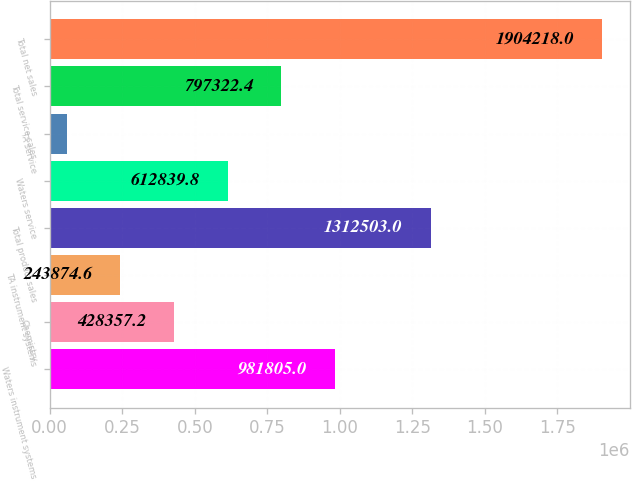Convert chart. <chart><loc_0><loc_0><loc_500><loc_500><bar_chart><fcel>Waters instrument systems<fcel>Chemistry<fcel>TA instrument systems<fcel>Total product sales<fcel>Waters service<fcel>TA service<fcel>Total service sales<fcel>Total net sales<nl><fcel>981805<fcel>428357<fcel>243875<fcel>1.3125e+06<fcel>612840<fcel>59392<fcel>797322<fcel>1.90422e+06<nl></chart> 